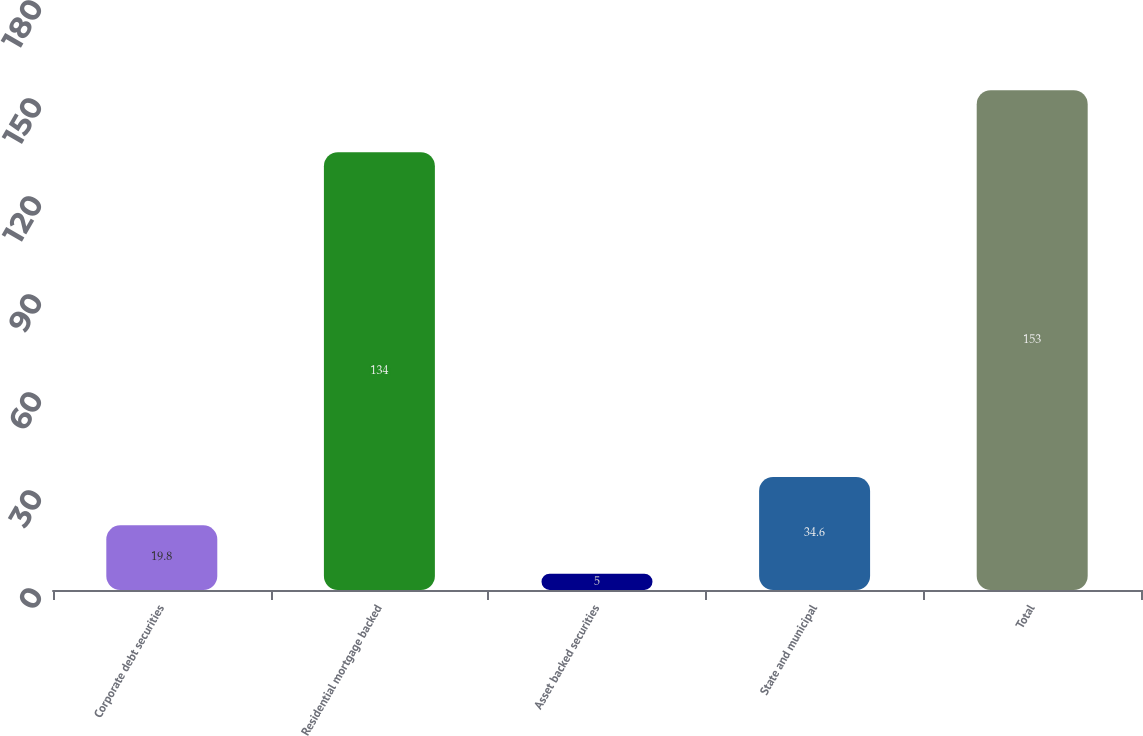<chart> <loc_0><loc_0><loc_500><loc_500><bar_chart><fcel>Corporate debt securities<fcel>Residential mortgage backed<fcel>Asset backed securities<fcel>State and municipal<fcel>Total<nl><fcel>19.8<fcel>134<fcel>5<fcel>34.6<fcel>153<nl></chart> 